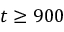Convert formula to latex. <formula><loc_0><loc_0><loc_500><loc_500>t \geq 9 0 0</formula> 